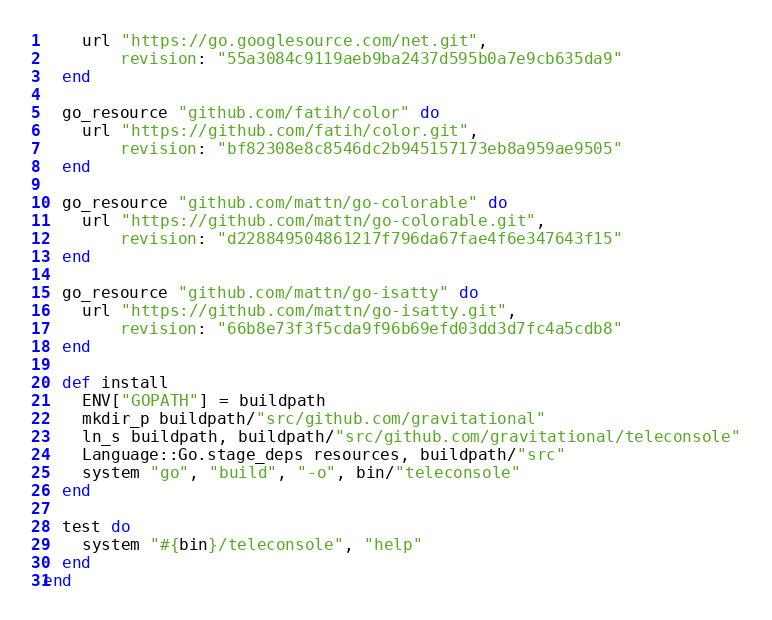<code> <loc_0><loc_0><loc_500><loc_500><_Ruby_>    url "https://go.googlesource.com/net.git",
        revision: "55a3084c9119aeb9ba2437d595b0a7e9cb635da9"
  end

  go_resource "github.com/fatih/color" do
    url "https://github.com/fatih/color.git",
        revision: "bf82308e8c8546dc2b945157173eb8a959ae9505"
  end

  go_resource "github.com/mattn/go-colorable" do
    url "https://github.com/mattn/go-colorable.git",
        revision: "d228849504861217f796da67fae4f6e347643f15"
  end

  go_resource "github.com/mattn/go-isatty" do
    url "https://github.com/mattn/go-isatty.git",
        revision: "66b8e73f3f5cda9f96b69efd03dd3d7fc4a5cdb8"
  end

  def install
    ENV["GOPATH"] = buildpath
    mkdir_p buildpath/"src/github.com/gravitational"
    ln_s buildpath, buildpath/"src/github.com/gravitational/teleconsole"
    Language::Go.stage_deps resources, buildpath/"src"
    system "go", "build", "-o", bin/"teleconsole"
  end

  test do
    system "#{bin}/teleconsole", "help"
  end
end
</code> 